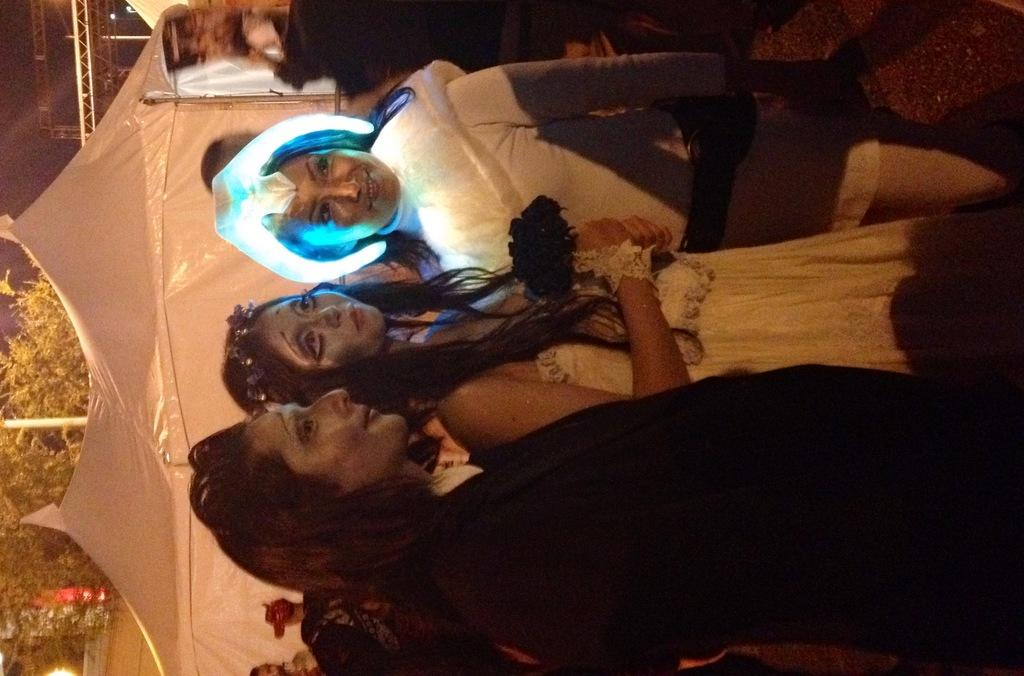How many people are in the image? There is a group of people in the image, but the exact number cannot be determined from the provided facts. What can be seen in the background of the image? There are tents, trees, and metal rods in the background of the image. What might the group of people be doing in the image? The activity of the group of people cannot be determined from the provided facts. What type of pest can be seen crawling on the camera in the image? There is no camera present in the image, and therefore no pest can be observed crawling on it. 